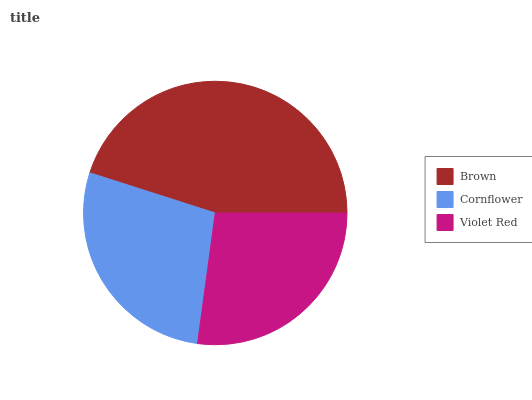Is Violet Red the minimum?
Answer yes or no. Yes. Is Brown the maximum?
Answer yes or no. Yes. Is Cornflower the minimum?
Answer yes or no. No. Is Cornflower the maximum?
Answer yes or no. No. Is Brown greater than Cornflower?
Answer yes or no. Yes. Is Cornflower less than Brown?
Answer yes or no. Yes. Is Cornflower greater than Brown?
Answer yes or no. No. Is Brown less than Cornflower?
Answer yes or no. No. Is Cornflower the high median?
Answer yes or no. Yes. Is Cornflower the low median?
Answer yes or no. Yes. Is Violet Red the high median?
Answer yes or no. No. Is Brown the low median?
Answer yes or no. No. 